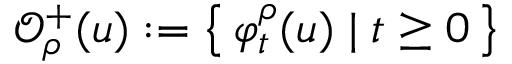<formula> <loc_0><loc_0><loc_500><loc_500>\mathcal { O } _ { \rho } ^ { + } ( u ) \colon = \left \{ \, \varphi _ { t } ^ { \rho } ( u ) \, | \, t \geq 0 \, \right \}</formula> 